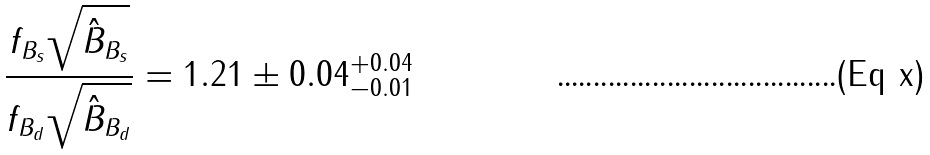<formula> <loc_0><loc_0><loc_500><loc_500>\frac { f _ { B _ { s } } \sqrt { \hat { B } _ { B _ { s } } } } { f _ { B _ { d } } \sqrt { \hat { B } _ { B _ { d } } } } = 1 . 2 1 \pm 0 . 0 4 ^ { + 0 . 0 4 } _ { - 0 . 0 1 }</formula> 